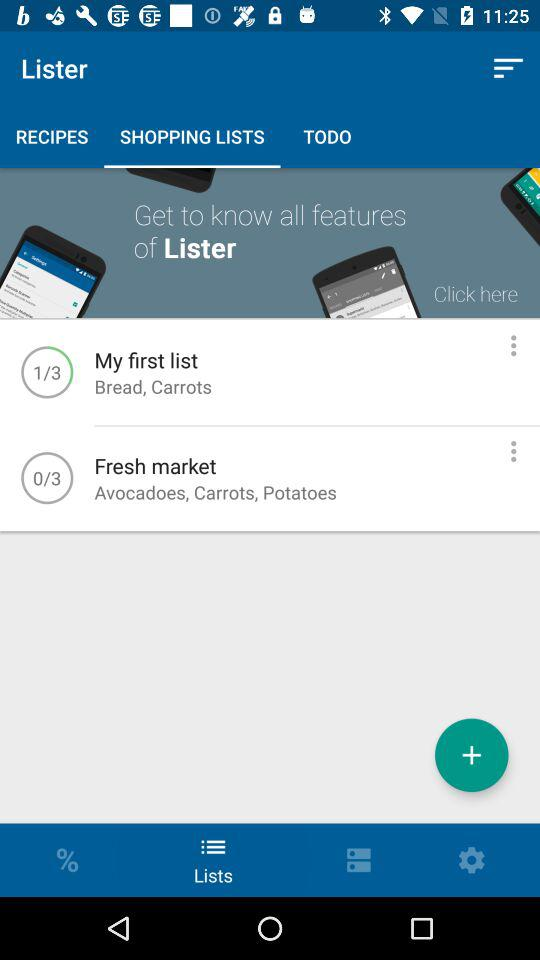How many total pages are there for "My first list"? The total pages are 3. 